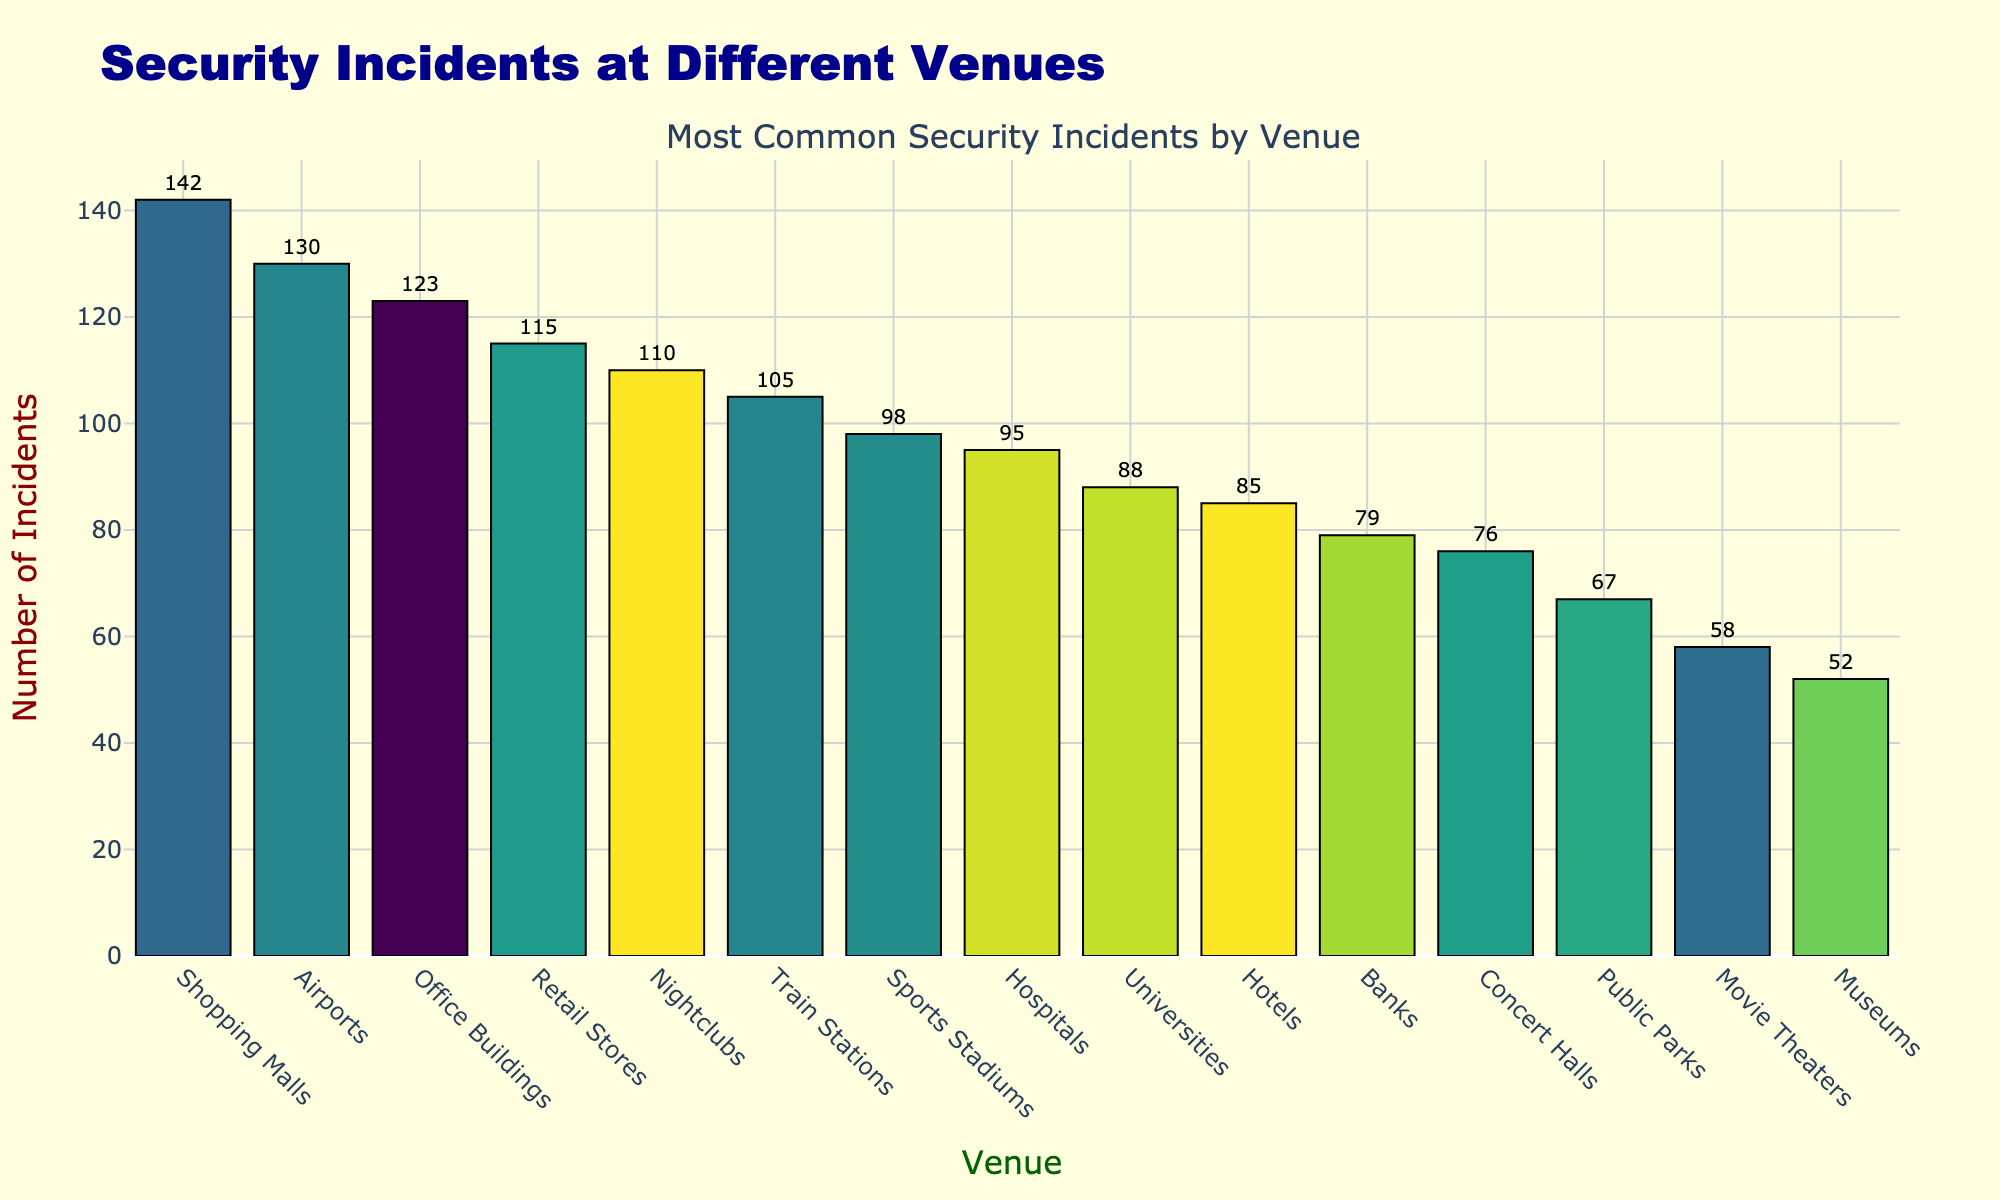Which venue has the highest number of security incidents reported? Identify the tallest bar in the figure and read the label that specifies the venue.
Answer: Shopping Malls How many more incidents were reported in Shopping Malls than in Museums? Find the height of the bar for Shopping Malls (142) and subtract the height of the bar for Museums (52).
Answer: 90 What is the total number of incidents reported in Nightclubs, Retail Stores, and Movie Theaters combined? Add the heights of the bars for Nightclubs (110), Retail Stores (115), and Movie Theaters (58).
Answer: 283 Are incidents reported more frequently at Sports Stadiums or Concert Halls? Compare the height of the bar for Sports Stadiums (98) with the height of the bar for Concert Halls (76).
Answer: Sports Stadiums What is the average number of incidents reported across all venues? Sum the incidents reported for all venues and divide by the number of venues (15). The total is 142 + 98 + 76 + 123 + 85 + 110 + 52 + 95 + 88 + 130 + 105 + 67 + 79 + 115 + 58 = 1323. Divide 1323 by 15.
Answer: 88.2 Which venue has the second highest number of security incidents? Identify the second tallest bar in the figure by comparing all bar heights.
Answer: Office Buildings What is the difference in incidents reported between Airports and Hotels? Subtract the number of incidents in Hotels (85) from the number of incidents in Airports (130).
Answer: 45 Are there more incidents reported at Hospitals or Universities? Compare the height of the bar for Hospitals (95) with the height of the bar for Universities (88).
Answer: Hospitals Which venue has the fewest security incidents reported? Identify the shortest bar in the figure and read the label that specifies the venue.
Answer: Museums By how much does the number of incidents reported at Train Stations exceed those reported at Banks? Subtract the number of incidents in Banks (79) from the number of incidents in Train Stations (105).
Answer: 26 